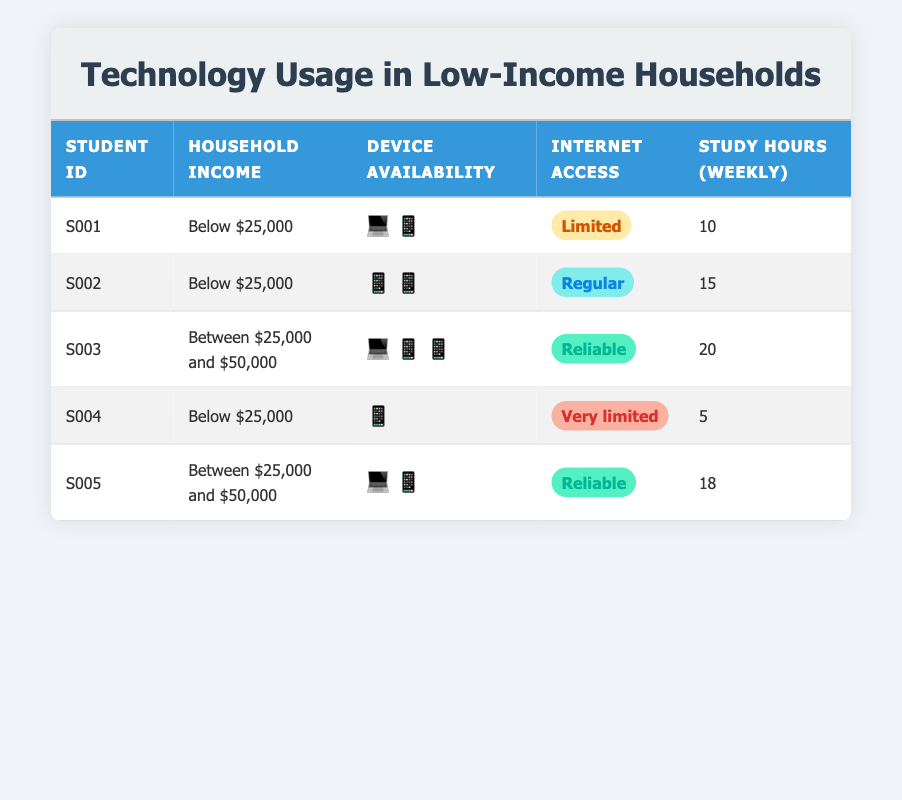What is the household income range for student S001? According to the table, S001's household income is listed as "Below $25,000."
Answer: Below $25,000 How many students have access to a laptop? From the table, we can see that S001, S003, and S005 have access to a laptop. This is a total of 3 students.
Answer: 3 What percentage of students have reliable internet access? There are 5 students in total. Only S003 and S005 have reliable internet access, which accounts for 2 students. To find the percentage, we calculate (2/5) * 100 = 40%.
Answer: 40% Is student S002 able to study on a laptop? The table shows that S002 does not have a laptop available for study as the "laptop" field under device availability is "false."
Answer: No Which student studies the most hours each week? To determine which student studies the most, we can compare the "study hours weekly" data. S003 studies 20 hours, which is the highest among all listed students.
Answer: S003 What is the average number of study hours for students with below $25,000 income? For students with below $25,000, the study hours are as follows: S001 (10), S002 (15), and S004 (5). Adding these gives 10 + 15 + 5 = 30. Dividing by the 3 students, we get an average of 30/3 = 10.
Answer: 10 How many students have access to both a smartphone and a tablet? The rows for each student show that students S002 and S003 have access to both devices. Hence, the count is 2 students who have both a smartphone and a tablet available.
Answer: 2 What is the device availability of student S004? Looking at S004's data, it shows that they have no laptop or tablet but do have a smartphone. Therefore, S004 has device availability as only a smartphone.
Answer: Smartphone only Which student studies the least per week? By reviewing the study hours for each student, S004, with only 5 hours of study weekly, has the least among all students listed.
Answer: S004 